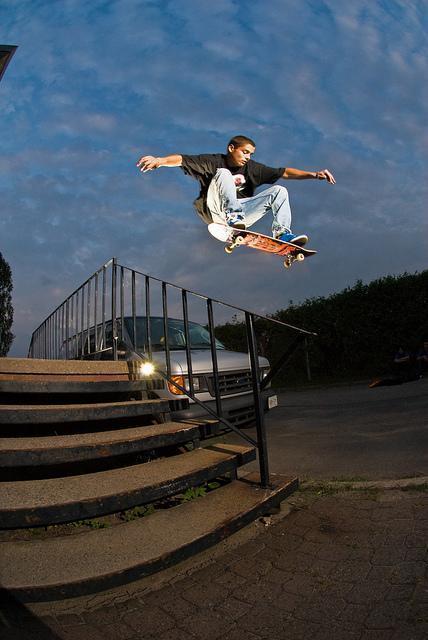The skateboarder would have to Ollie at least how high to clear the top of the railing?
Select the correct answer and articulate reasoning with the following format: 'Answer: answer
Rationale: rationale.'
Options: 12 feet, 8 feet, 5 feet, 3 feet. Answer: 3 feet.
Rationale: The railing is going to be three feet since it's waist high. 